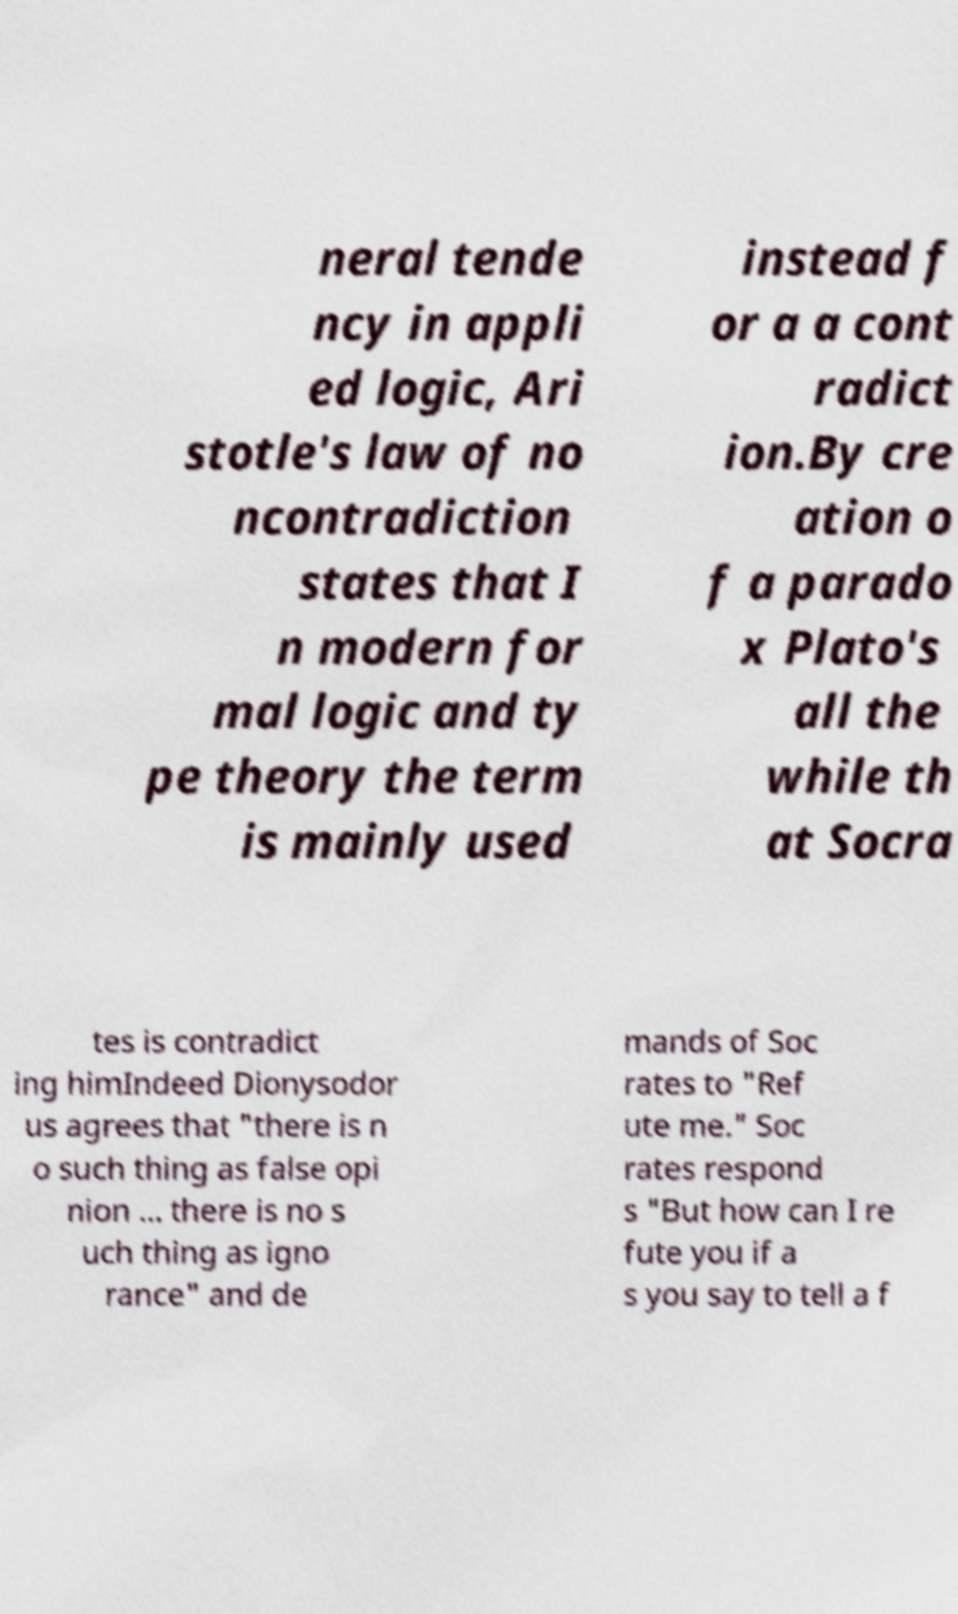For documentation purposes, I need the text within this image transcribed. Could you provide that? neral tende ncy in appli ed logic, Ari stotle's law of no ncontradiction states that I n modern for mal logic and ty pe theory the term is mainly used instead f or a a cont radict ion.By cre ation o f a parado x Plato's all the while th at Socra tes is contradict ing himIndeed Dionysodor us agrees that "there is n o such thing as false opi nion ... there is no s uch thing as igno rance" and de mands of Soc rates to "Ref ute me." Soc rates respond s "But how can I re fute you if a s you say to tell a f 